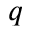<formula> <loc_0><loc_0><loc_500><loc_500>q</formula> 